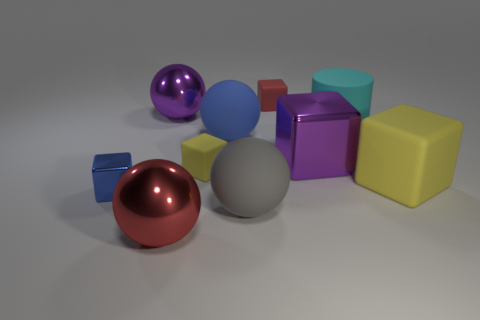Subtract all tiny yellow blocks. How many blocks are left? 4 Subtract all red balls. How many balls are left? 3 Subtract all cylinders. How many objects are left? 9 Subtract all brown balls. Subtract all cyan cylinders. How many balls are left? 4 Add 3 big metallic cubes. How many big metallic cubes are left? 4 Add 9 brown metal things. How many brown metal things exist? 9 Subtract 1 yellow cubes. How many objects are left? 9 Subtract all big cyan rubber cylinders. Subtract all cyan rubber things. How many objects are left? 8 